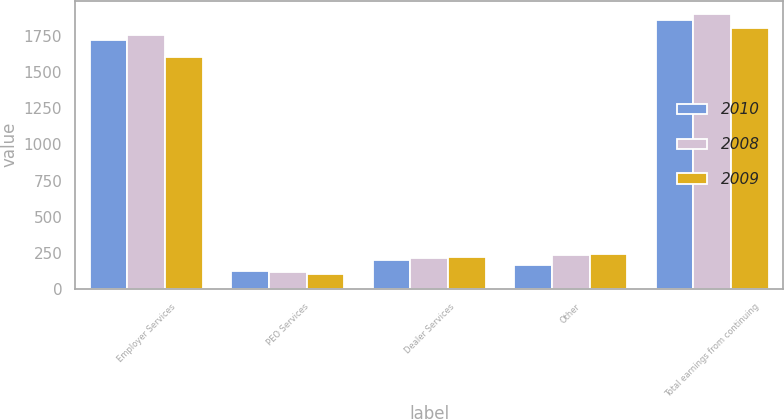Convert chart to OTSL. <chart><loc_0><loc_0><loc_500><loc_500><stacked_bar_chart><ecel><fcel>Employer Services<fcel>PEO Services<fcel>Dealer Services<fcel>Other<fcel>Total earnings from continuing<nl><fcel>2010<fcel>1722.4<fcel>126.6<fcel>201<fcel>167.8<fcel>1863.2<nl><fcel>2008<fcel>1758.7<fcel>117.6<fcel>214.3<fcel>233.5<fcel>1900.1<nl><fcel>2009<fcel>1606.7<fcel>102<fcel>220.1<fcel>245.4<fcel>1803.4<nl></chart> 